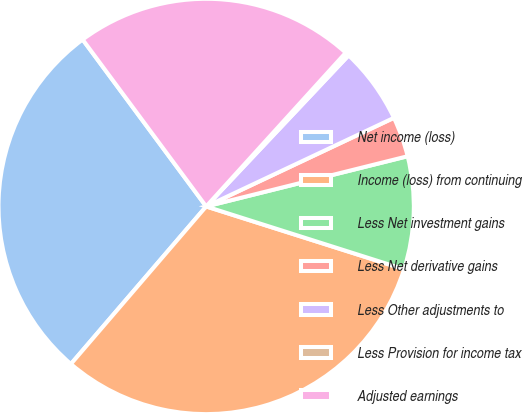Convert chart to OTSL. <chart><loc_0><loc_0><loc_500><loc_500><pie_chart><fcel>Net income (loss)<fcel>Income (loss) from continuing<fcel>Less Net investment gains<fcel>Less Net derivative gains<fcel>Less Other adjustments to<fcel>Less Provision for income tax<fcel>Adjusted earnings<nl><fcel>28.57%<fcel>31.4%<fcel>8.78%<fcel>3.13%<fcel>5.95%<fcel>0.3%<fcel>21.87%<nl></chart> 